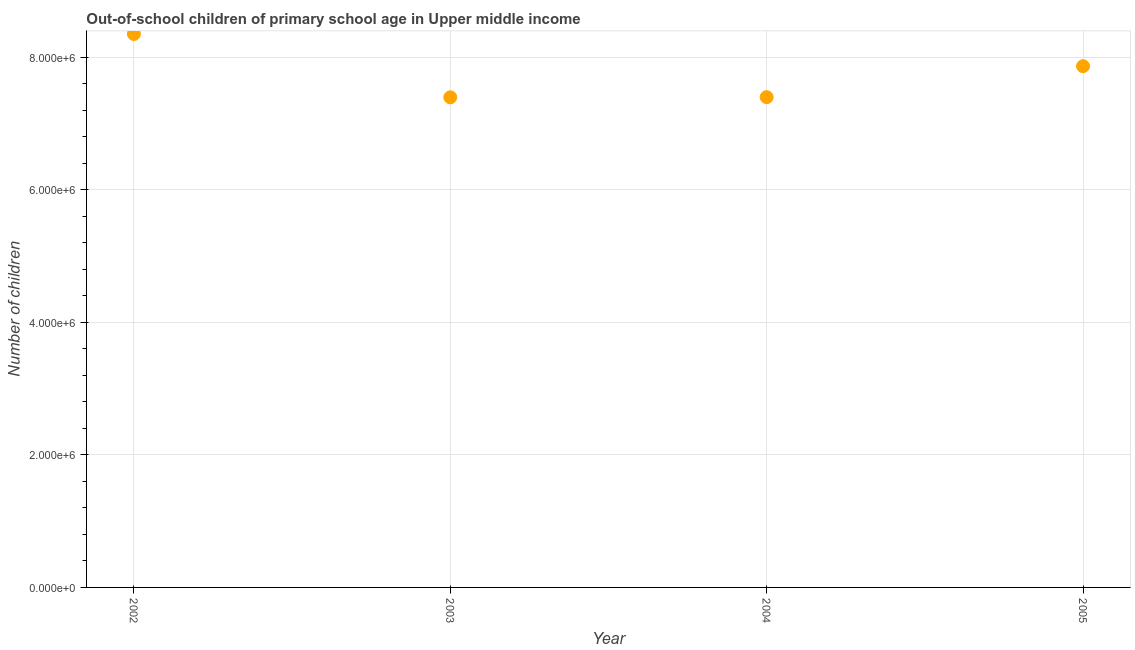What is the number of out-of-school children in 2005?
Offer a terse response. 7.86e+06. Across all years, what is the maximum number of out-of-school children?
Give a very brief answer. 8.35e+06. Across all years, what is the minimum number of out-of-school children?
Provide a short and direct response. 7.39e+06. In which year was the number of out-of-school children minimum?
Make the answer very short. 2003. What is the sum of the number of out-of-school children?
Provide a succinct answer. 3.10e+07. What is the difference between the number of out-of-school children in 2003 and 2005?
Offer a terse response. -4.70e+05. What is the average number of out-of-school children per year?
Provide a succinct answer. 7.75e+06. What is the median number of out-of-school children?
Provide a short and direct response. 7.63e+06. In how many years, is the number of out-of-school children greater than 2800000 ?
Your response must be concise. 4. What is the ratio of the number of out-of-school children in 2002 to that in 2003?
Your answer should be compact. 1.13. What is the difference between the highest and the second highest number of out-of-school children?
Provide a short and direct response. 4.86e+05. Is the sum of the number of out-of-school children in 2003 and 2005 greater than the maximum number of out-of-school children across all years?
Provide a succinct answer. Yes. What is the difference between the highest and the lowest number of out-of-school children?
Ensure brevity in your answer.  9.56e+05. In how many years, is the number of out-of-school children greater than the average number of out-of-school children taken over all years?
Give a very brief answer. 2. How many dotlines are there?
Your answer should be very brief. 1. What is the title of the graph?
Make the answer very short. Out-of-school children of primary school age in Upper middle income. What is the label or title of the X-axis?
Ensure brevity in your answer.  Year. What is the label or title of the Y-axis?
Provide a short and direct response. Number of children. What is the Number of children in 2002?
Ensure brevity in your answer.  8.35e+06. What is the Number of children in 2003?
Provide a succinct answer. 7.39e+06. What is the Number of children in 2004?
Offer a very short reply. 7.40e+06. What is the Number of children in 2005?
Offer a terse response. 7.86e+06. What is the difference between the Number of children in 2002 and 2003?
Give a very brief answer. 9.56e+05. What is the difference between the Number of children in 2002 and 2004?
Your answer should be very brief. 9.53e+05. What is the difference between the Number of children in 2002 and 2005?
Give a very brief answer. 4.86e+05. What is the difference between the Number of children in 2003 and 2004?
Offer a terse response. -2660. What is the difference between the Number of children in 2003 and 2005?
Your answer should be very brief. -4.70e+05. What is the difference between the Number of children in 2004 and 2005?
Offer a terse response. -4.67e+05. What is the ratio of the Number of children in 2002 to that in 2003?
Provide a succinct answer. 1.13. What is the ratio of the Number of children in 2002 to that in 2004?
Offer a very short reply. 1.13. What is the ratio of the Number of children in 2002 to that in 2005?
Ensure brevity in your answer.  1.06. What is the ratio of the Number of children in 2003 to that in 2004?
Offer a terse response. 1. What is the ratio of the Number of children in 2003 to that in 2005?
Your answer should be very brief. 0.94. What is the ratio of the Number of children in 2004 to that in 2005?
Your answer should be compact. 0.94. 